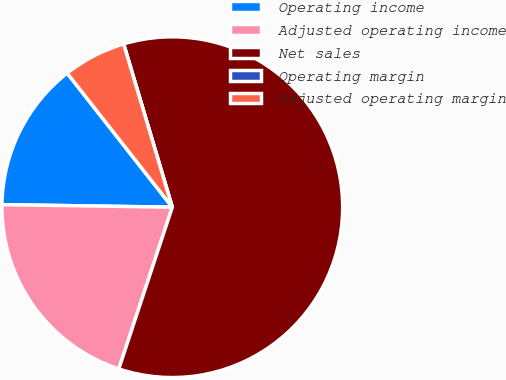Convert chart to OTSL. <chart><loc_0><loc_0><loc_500><loc_500><pie_chart><fcel>Operating income<fcel>Adjusted operating income<fcel>Net sales<fcel>Operating margin<fcel>Adjusted operating margin<nl><fcel>14.18%<fcel>20.15%<fcel>59.69%<fcel>0.0%<fcel>5.97%<nl></chart> 